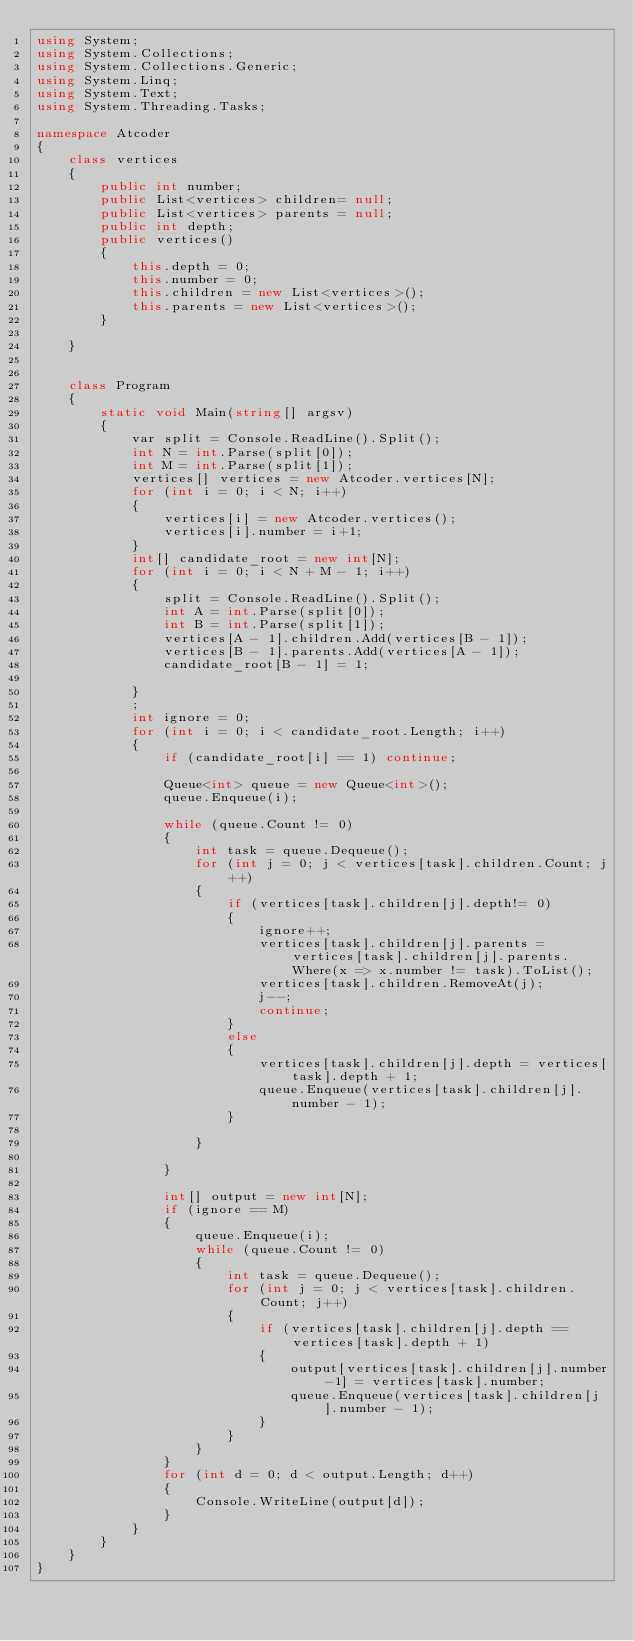Convert code to text. <code><loc_0><loc_0><loc_500><loc_500><_C#_>using System;
using System.Collections;
using System.Collections.Generic;
using System.Linq;
using System.Text;
using System.Threading.Tasks;

namespace Atcoder
{
    class vertices
    {
        public int number;
        public List<vertices> children= null;
        public List<vertices> parents = null;
        public int depth;
        public vertices()
        {
            this.depth = 0;
            this.number = 0;
            this.children = new List<vertices>();
            this.parents = new List<vertices>();
        }

    }


    class Program
    {
        static void Main(string[] argsv)
        {
            var split = Console.ReadLine().Split();
            int N = int.Parse(split[0]);
            int M = int.Parse(split[1]);
            vertices[] vertices = new Atcoder.vertices[N];
            for (int i = 0; i < N; i++)
            {
                vertices[i] = new Atcoder.vertices();
                vertices[i].number = i+1;
            }
            int[] candidate_root = new int[N];
            for (int i = 0; i < N + M - 1; i++)
            {
                split = Console.ReadLine().Split();
                int A = int.Parse(split[0]);
                int B = int.Parse(split[1]);
                vertices[A - 1].children.Add(vertices[B - 1]);
                vertices[B - 1].parents.Add(vertices[A - 1]);
                candidate_root[B - 1] = 1;

            }
            ;
            int ignore = 0;
            for (int i = 0; i < candidate_root.Length; i++)
            {
                if (candidate_root[i] == 1) continue;

                Queue<int> queue = new Queue<int>();
                queue.Enqueue(i);

                while (queue.Count != 0)
                {
                    int task = queue.Dequeue();
                    for (int j = 0; j < vertices[task].children.Count; j++)
                    {
                        if (vertices[task].children[j].depth!= 0)
                        {
                            ignore++;
                            vertices[task].children[j].parents = vertices[task].children[j].parents.Where(x => x.number != task).ToList();
                            vertices[task].children.RemoveAt(j);
                            j--;
                            continue;
                        }
                        else
                        {
                            vertices[task].children[j].depth = vertices[task].depth + 1;
                            queue.Enqueue(vertices[task].children[j].number - 1);
                        }

                    }

                }

                int[] output = new int[N];
                if (ignore == M)
                {
                    queue.Enqueue(i);
                    while (queue.Count != 0)
                    {
                        int task = queue.Dequeue();
                        for (int j = 0; j < vertices[task].children.Count; j++)
                        {
                            if (vertices[task].children[j].depth == vertices[task].depth + 1)
                            {
                                output[vertices[task].children[j].number-1] = vertices[task].number;
                                queue.Enqueue(vertices[task].children[j].number - 1);
                            }
                        }
                    }
                }
                for (int d = 0; d < output.Length; d++)
                {
                    Console.WriteLine(output[d]);
                }
            }
        }
    }
}</code> 